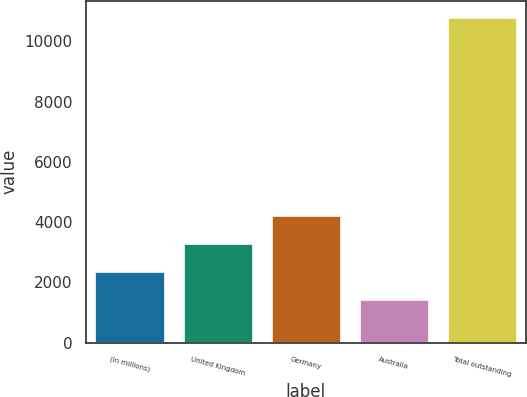Convert chart. <chart><loc_0><loc_0><loc_500><loc_500><bar_chart><fcel>(In millions)<fcel>United Kingdom<fcel>Germany<fcel>Australia<fcel>Total outstanding<nl><fcel>2377.8<fcel>3314.6<fcel>4251.4<fcel>1441<fcel>10809<nl></chart> 